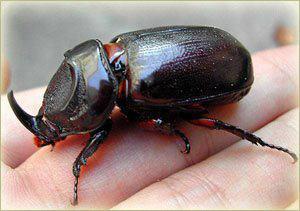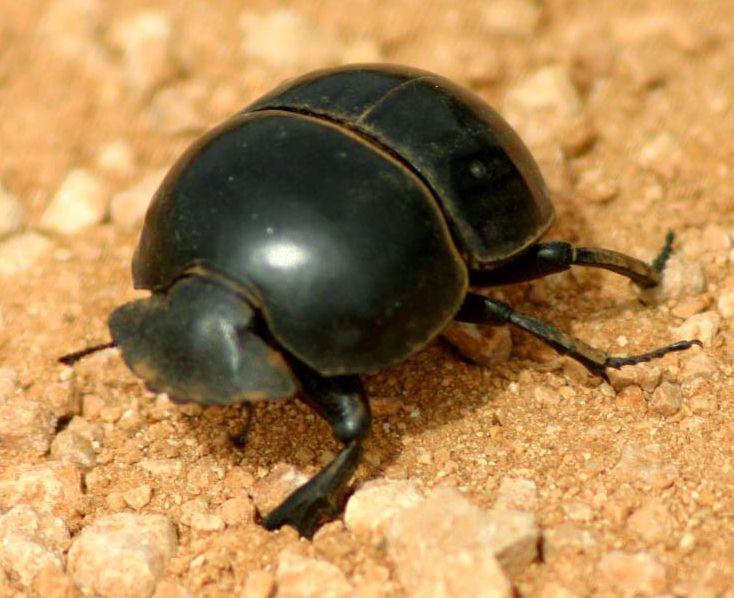The first image is the image on the left, the second image is the image on the right. For the images shown, is this caption "The insect in one of the images is standing upon a green leaf." true? Answer yes or no. No. 